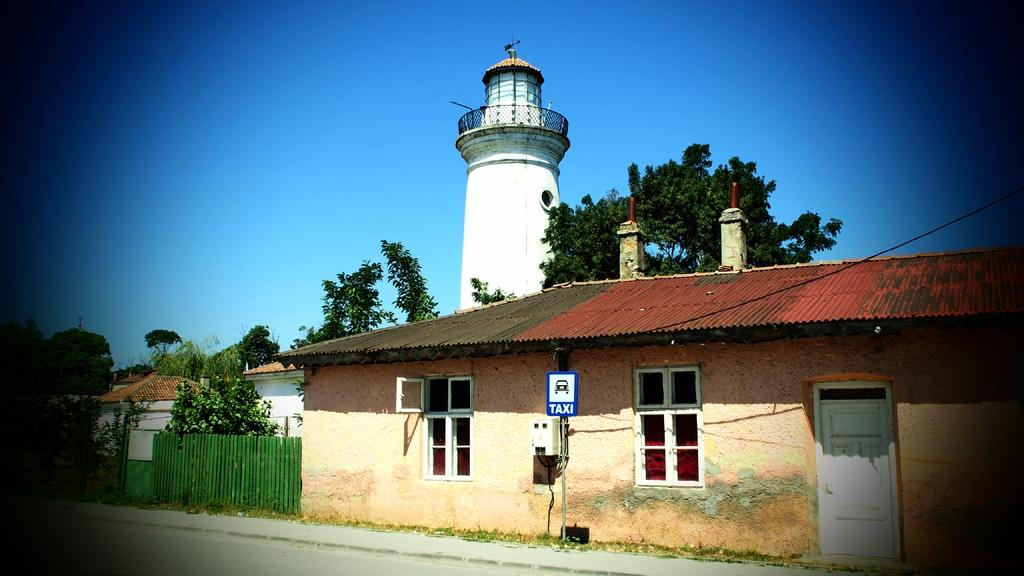What type of structures can be seen in the image? There are houses in the image. What type of vegetation is present in the image? There are trees in the image. What tall structure can be seen in the image? There is a tower in the image. What type of barrier is present in the image? There is a fence in the image. What is visible at the top of the image? The sky is visible at the top of the image. What type of pathway is visible at the bottom of the image? There is a road visible at the bottom of the image. What type of patch is visible on the tower in the image? There is no patch visible on the tower in the image. What type of expansion is shown in the image? The image does not depict any expansion; it shows a static scene with houses, trees, a tower, a fence, the sky, and a road. 